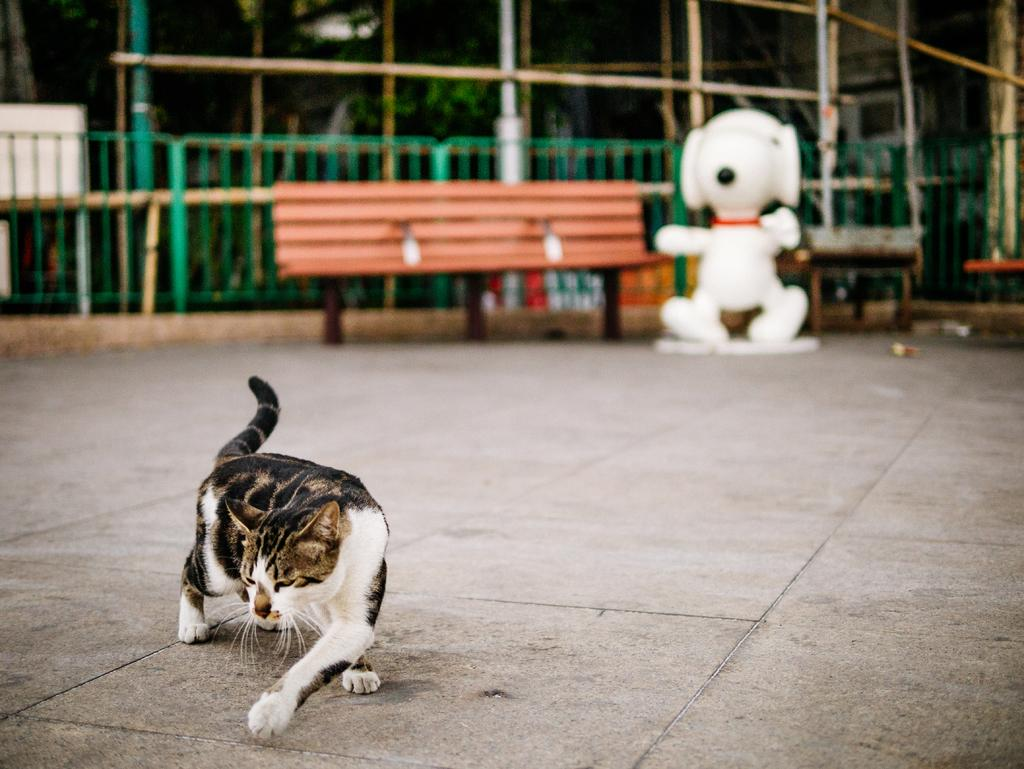What type of animal is present in the image? There is a cat in the image. What can be seen in the background of the image? There is a bench, a toy, a metal fence, and trees in the background of the image. How many babies are holding the pin in the image? There are no babies or pins present in the image. 